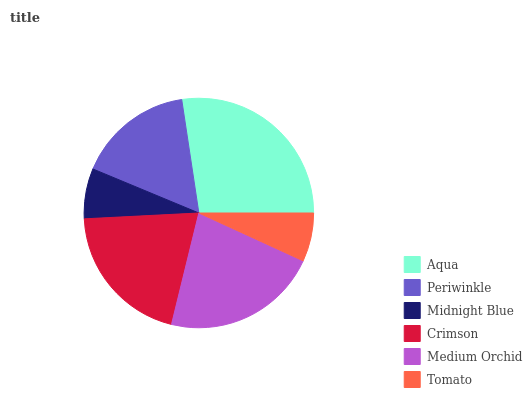Is Tomato the minimum?
Answer yes or no. Yes. Is Aqua the maximum?
Answer yes or no. Yes. Is Periwinkle the minimum?
Answer yes or no. No. Is Periwinkle the maximum?
Answer yes or no. No. Is Aqua greater than Periwinkle?
Answer yes or no. Yes. Is Periwinkle less than Aqua?
Answer yes or no. Yes. Is Periwinkle greater than Aqua?
Answer yes or no. No. Is Aqua less than Periwinkle?
Answer yes or no. No. Is Crimson the high median?
Answer yes or no. Yes. Is Periwinkle the low median?
Answer yes or no. Yes. Is Medium Orchid the high median?
Answer yes or no. No. Is Crimson the low median?
Answer yes or no. No. 